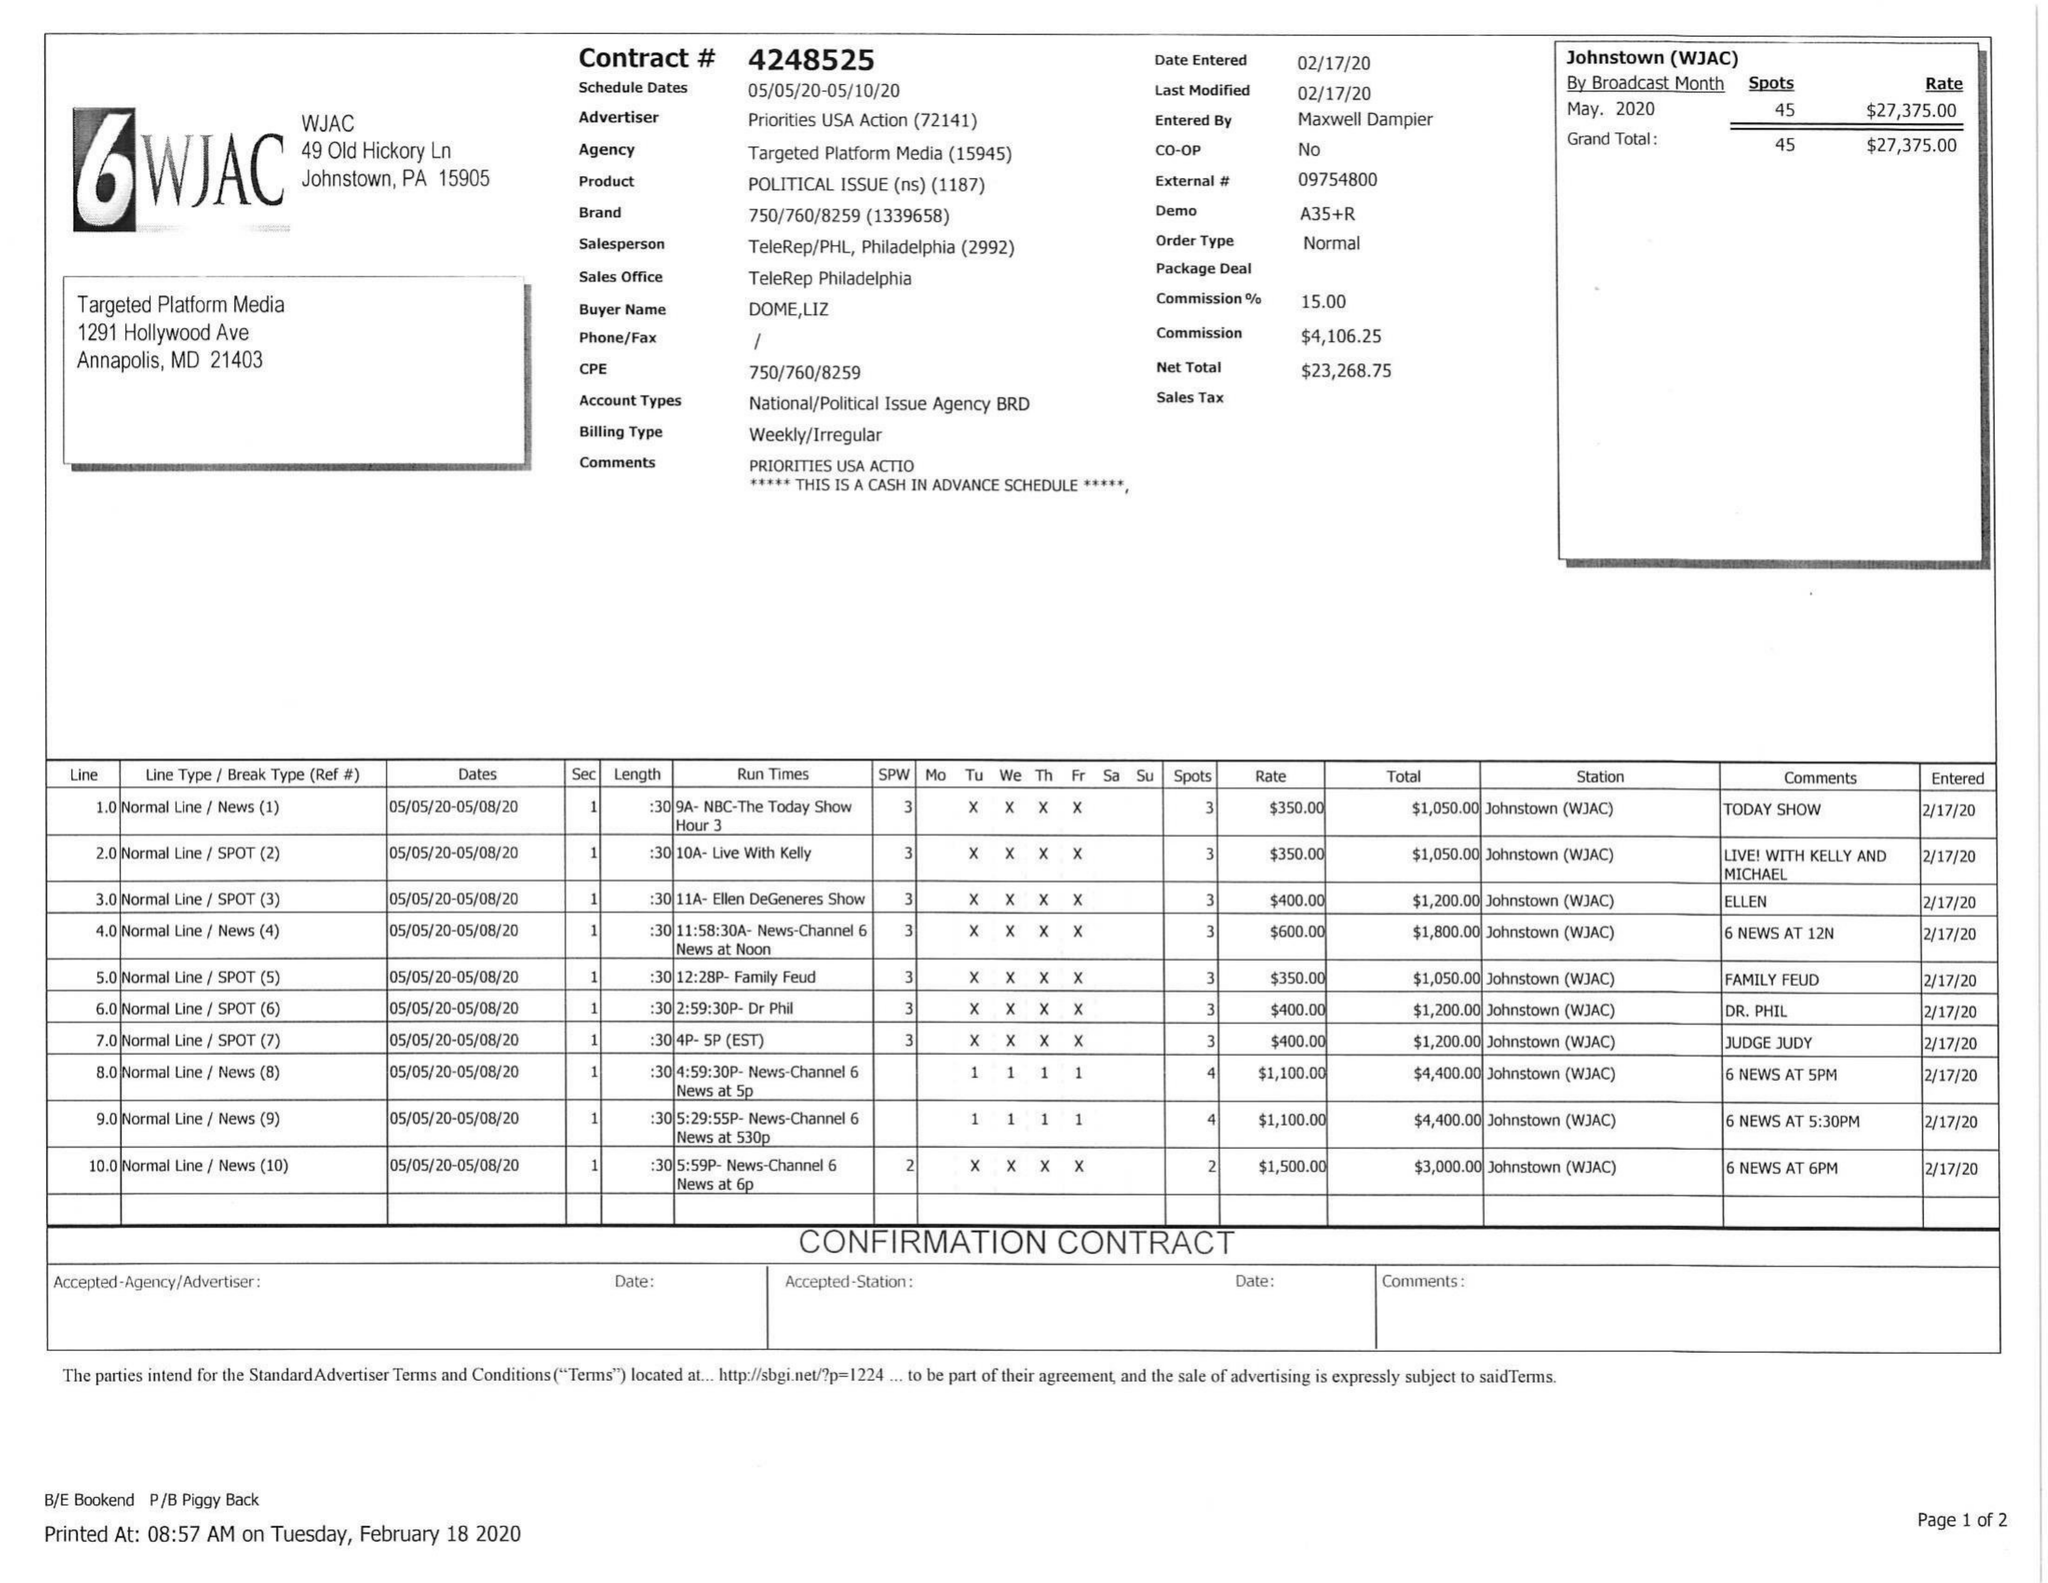What is the value for the advertiser?
Answer the question using a single word or phrase. PRIORITIES USA ACTION 